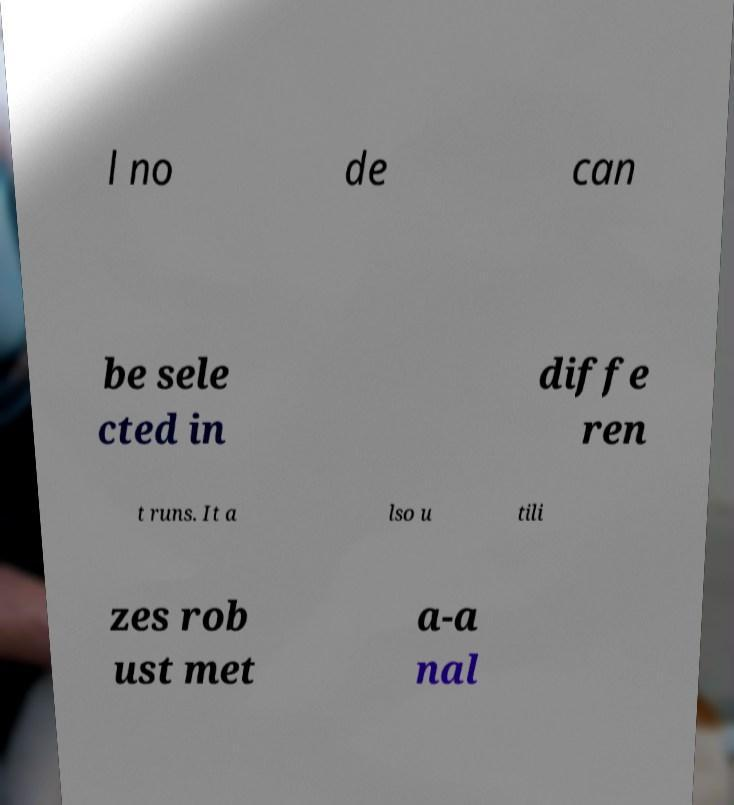For documentation purposes, I need the text within this image transcribed. Could you provide that? l no de can be sele cted in diffe ren t runs. It a lso u tili zes rob ust met a-a nal 